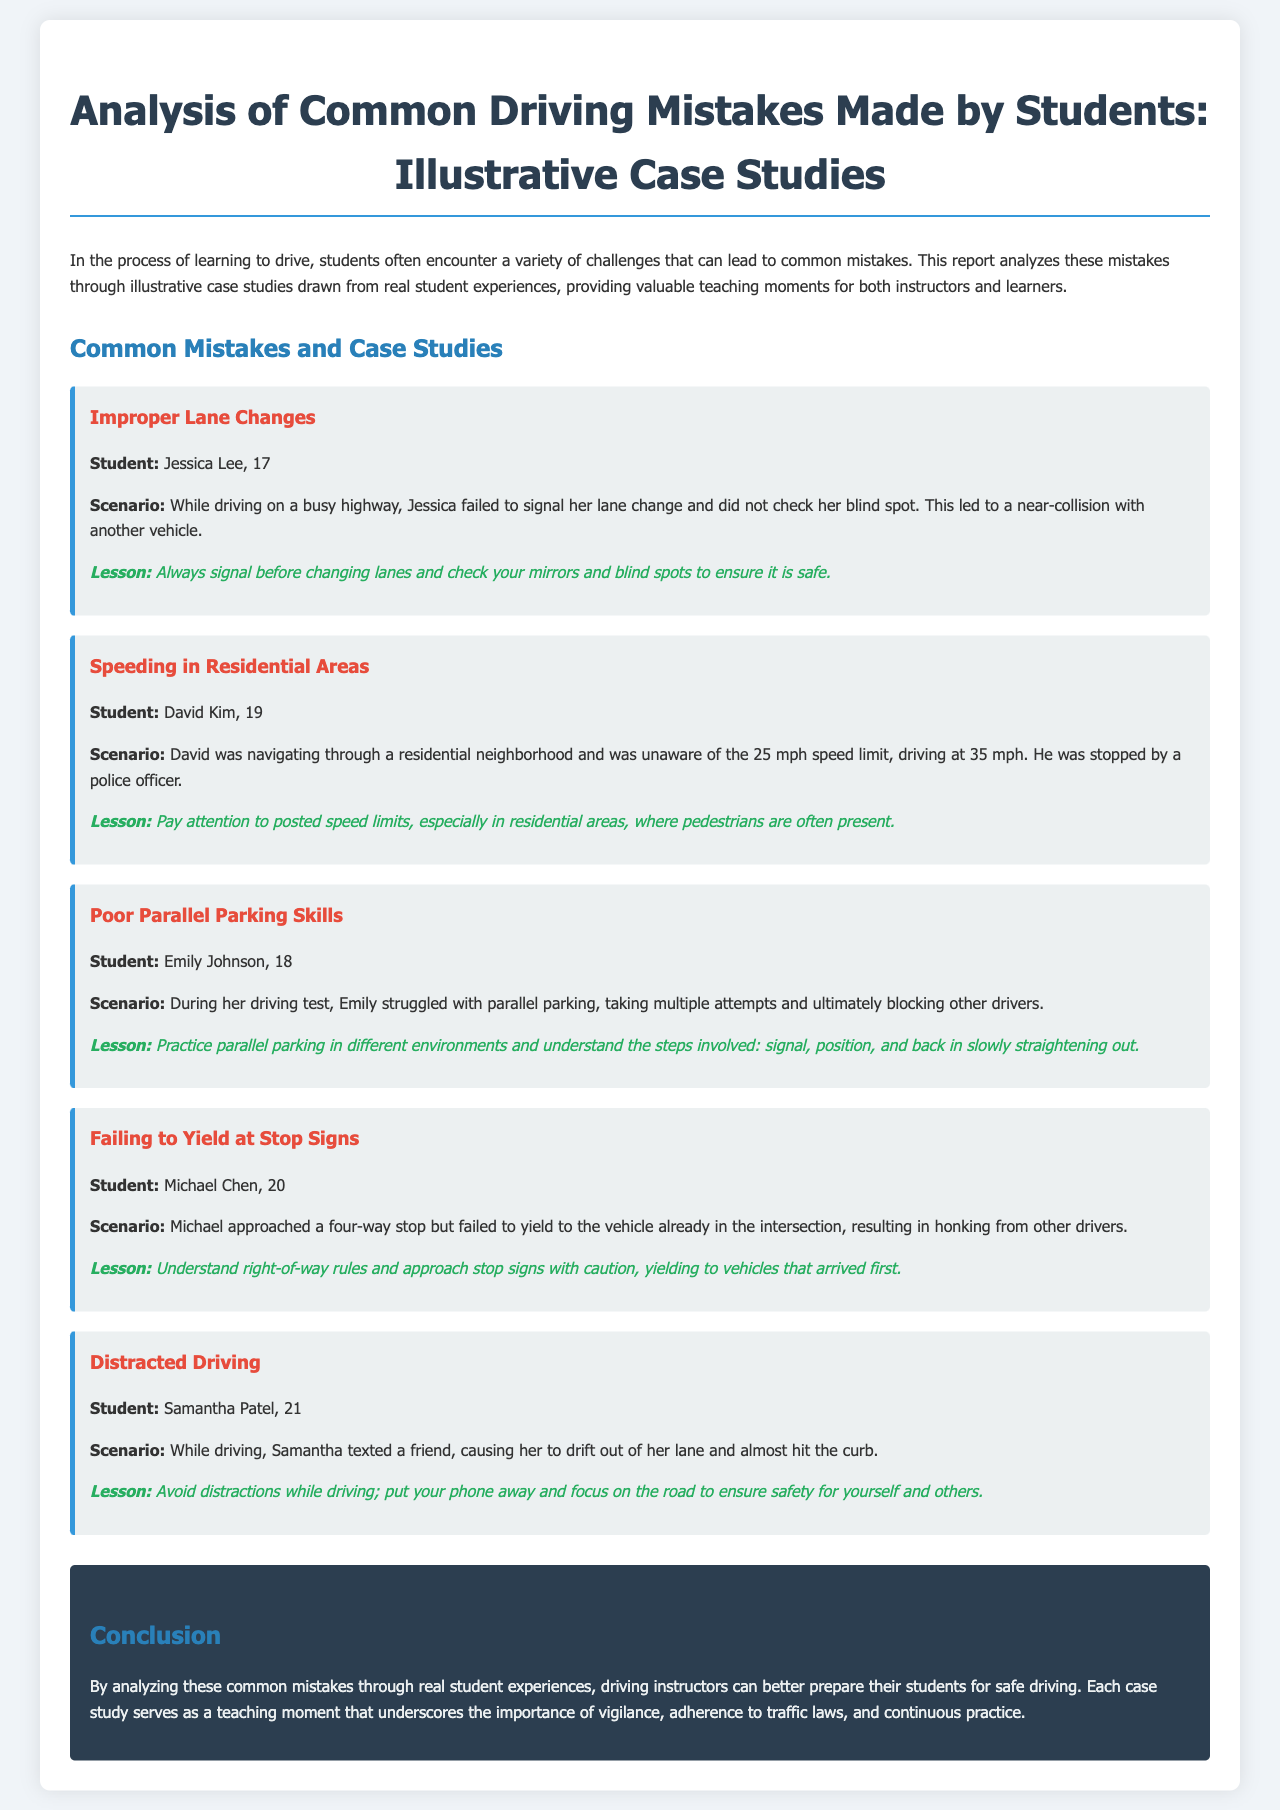What is the title of the report? The title of the report is presented prominently at the beginning, indicating the focus on driving mistakes and case studies.
Answer: Analysis of Common Driving Mistakes: A Teaching Guide Who is the first case study about? The first case study highlights a student who made a mistake while changing lanes, specifically named in the introduction to the case study.
Answer: Jessica Lee What mistake did David Kim make? The document specifies David's error as he drove faster than the posted speed limit in a residential area.
Answer: Speeding in Residential Areas What lesson is emphasized in the case of Emily Johnson? The lesson derived from Emily's experience is centered around improving a specific driving skill.
Answer: Practice parallel parking in different environments How many students' mistakes are discussed in the report? The report outlines mistakes made by students as individual case studies, enumerating each instance.
Answer: Five 